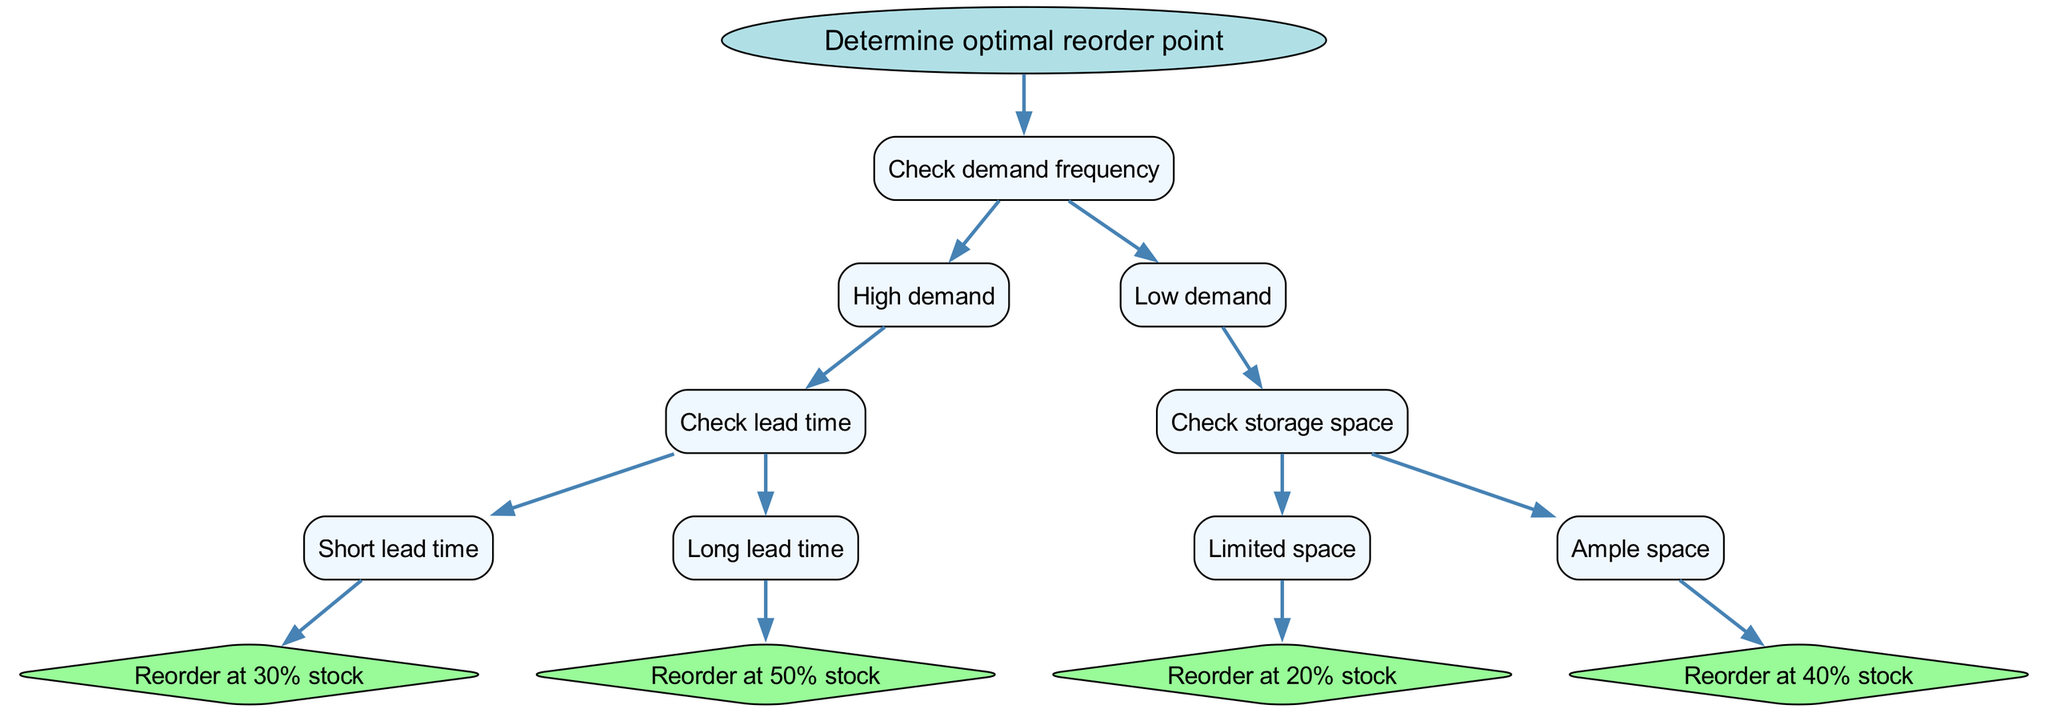What is the root node of this decision tree? The root node, which is the starting point of the decision tree, is "Determine optimal reorder point."
Answer: Determine optimal reorder point How many main branches does the tree have? The tree has one main branch from the root, which splits into two child nodes: "Check demand frequency."
Answer: One What is the reorder point for high demand and short lead time? In the scenario of high demand and short lead time, the decision leads to "Reorder at 30% stock."
Answer: Reorder at 30% stock What happens if demand is low and storage space is limited? If demand is low and storage space is limited, the decision leads to "Reorder at 20% stock."
Answer: Reorder at 20% stock What are the two potential lead time conditions in the high demand scenario? The two potential lead time conditions under high demand are "Short lead time" and "Long lead time."
Answer: Short lead time, Long lead time If the demand is low but there is ample storage space, what is the reorder recommendation? In the scenario of low demand with ample storage space, the decision leads to "Reorder at 40% stock."
Answer: Reorder at 40% stock How does the number of children nodes differ between high and low demand scenarios? The high demand scenario directly leads to two lead time conditions (short and long), while the low demand scenario leads to storage space considerations, making it two children for each group.
Answer: Same number of children nodes What is the reorder point at the end of the "Short lead time" path? Following the path from "Short lead time," the final decision is to "Reorder at 30% stock."
Answer: Reorder at 30% stock 